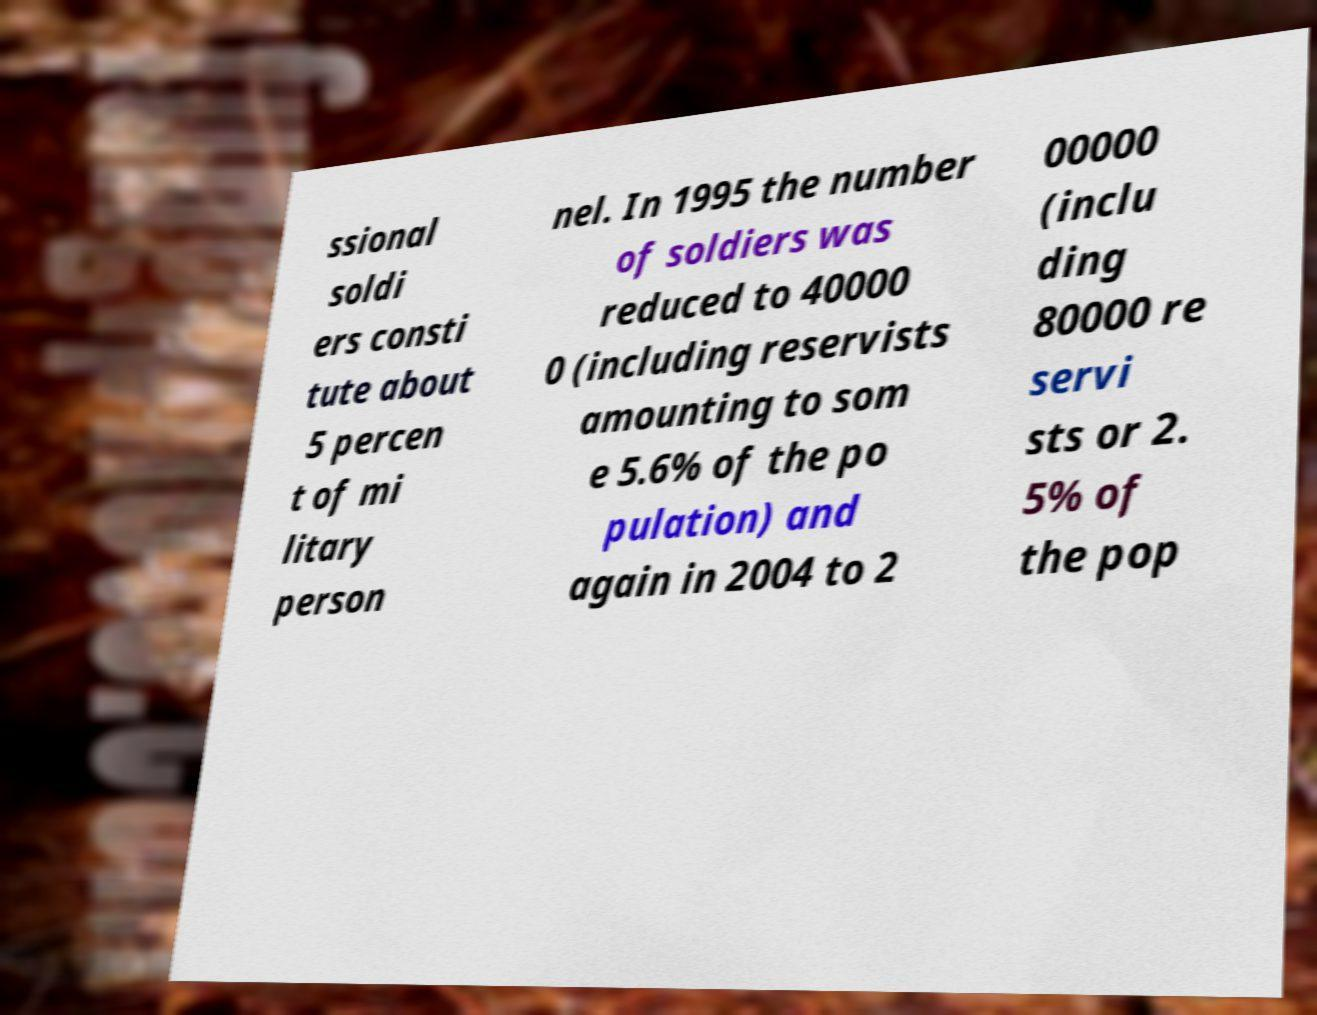For documentation purposes, I need the text within this image transcribed. Could you provide that? ssional soldi ers consti tute about 5 percen t of mi litary person nel. In 1995 the number of soldiers was reduced to 40000 0 (including reservists amounting to som e 5.6% of the po pulation) and again in 2004 to 2 00000 (inclu ding 80000 re servi sts or 2. 5% of the pop 